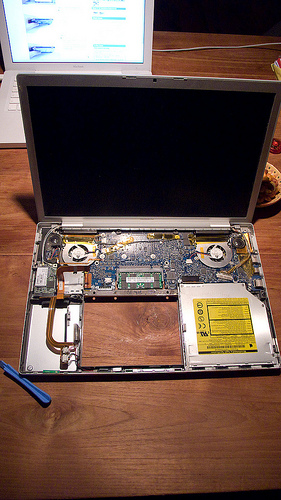<image>
Is the monitor above the wood? Yes. The monitor is positioned above the wood in the vertical space, higher up in the scene. 